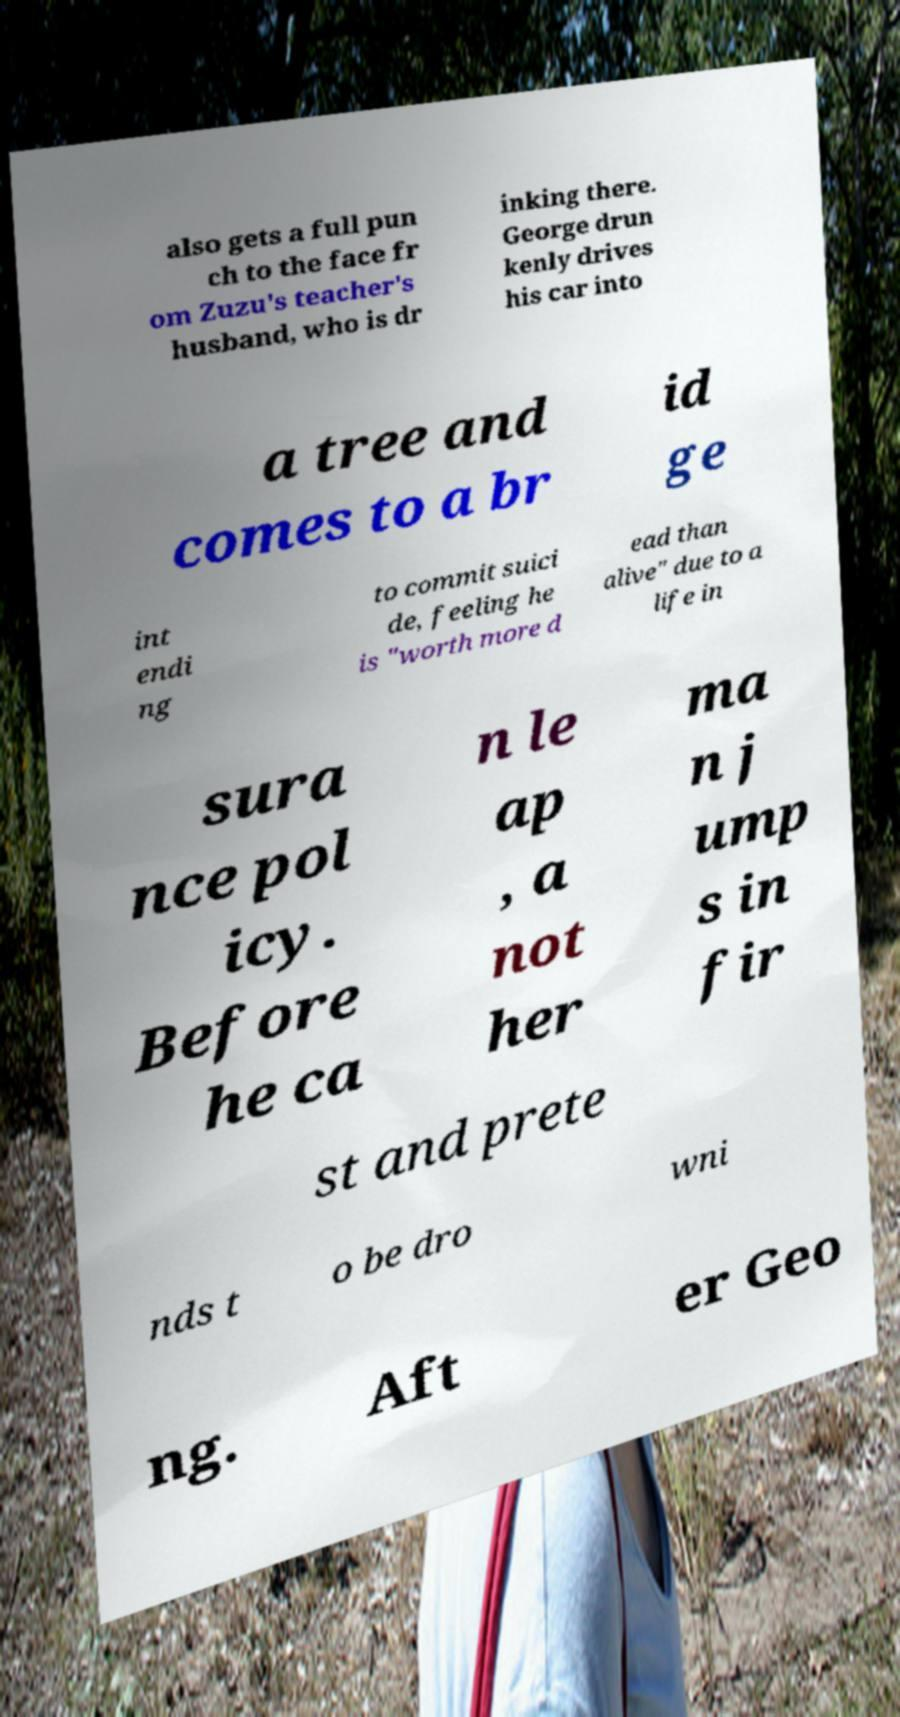Please read and relay the text visible in this image. What does it say? also gets a full pun ch to the face fr om Zuzu's teacher's husband, who is dr inking there. George drun kenly drives his car into a tree and comes to a br id ge int endi ng to commit suici de, feeling he is "worth more d ead than alive" due to a life in sura nce pol icy. Before he ca n le ap , a not her ma n j ump s in fir st and prete nds t o be dro wni ng. Aft er Geo 